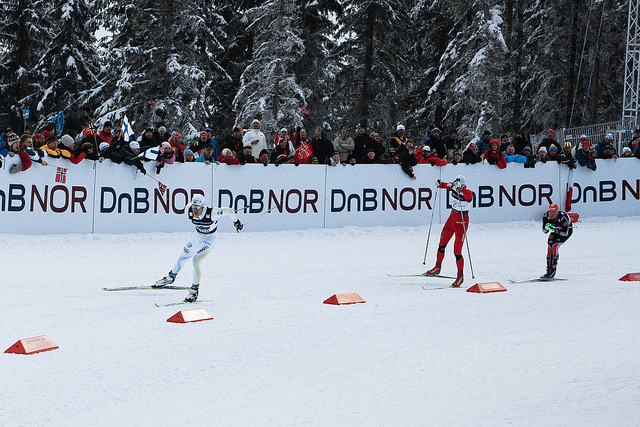Please identify all text content in this image. DnBN BNOR DnBNOR DnBNOR DnBNOR DnBNOR 